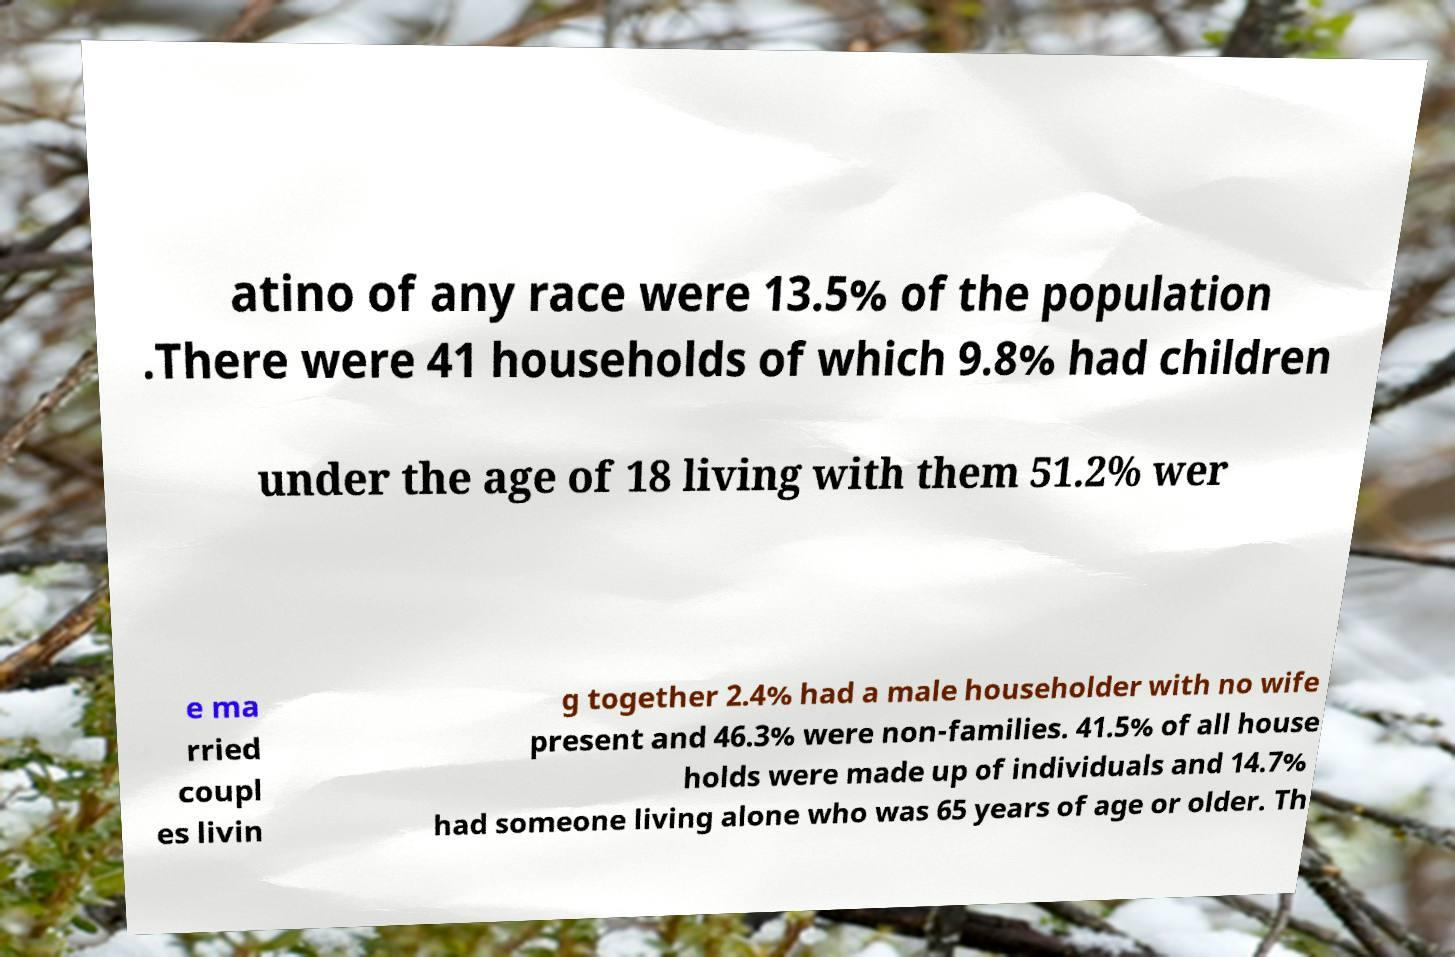What messages or text are displayed in this image? I need them in a readable, typed format. atino of any race were 13.5% of the population .There were 41 households of which 9.8% had children under the age of 18 living with them 51.2% wer e ma rried coupl es livin g together 2.4% had a male householder with no wife present and 46.3% were non-families. 41.5% of all house holds were made up of individuals and 14.7% had someone living alone who was 65 years of age or older. Th 